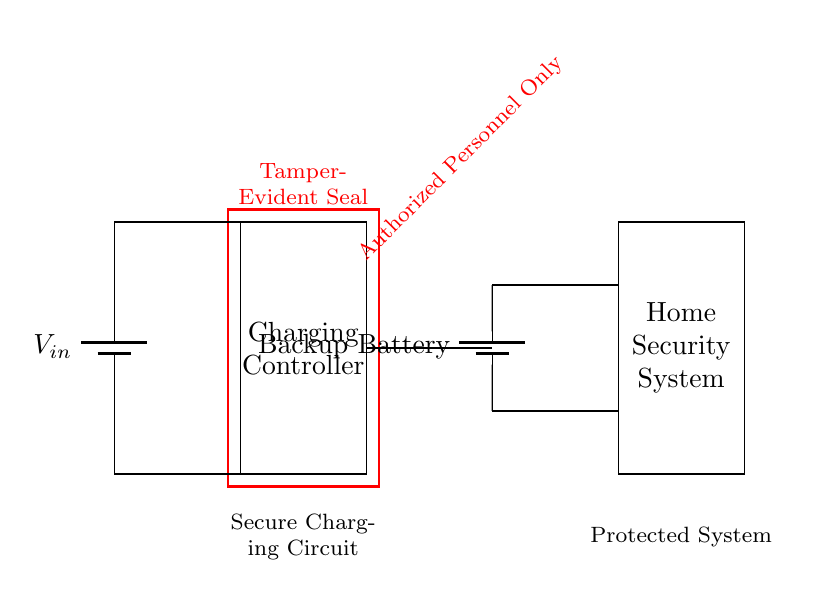What is the input voltage in this circuit? The input voltage is indicated as V in, which represents the voltage supplied to the charging circuit.
Answer: V in How many main components are in the circuit? There are four main components: a battery, a charging controller, a tamper-evident seal, and a home security system.
Answer: Four What is the purpose of the tamper-evident seal? The tamper-evident seal serves to protect the circuit from unauthorized access, ensuring that only authorized personnel can interact with the system.
Answer: Protects against tampering What happens to the backup battery during charging? During charging, the backup battery receives power from the input voltage through the charging controller, which regulates the process.
Answer: Receives power How does the circuit ensure secure charging? The charging circuit ensures secure charging by incorporating the tamper-evident seal that visually indicates if unauthorized access has occurred, alongside the regulated charging process from the controller.
Answer: Through tamper-evident seal and controller What is the connection between the charging controller and the backup battery? The charging controller connects to the backup battery, allowing it to manage the charging process and ensure the battery functions correctly within the circuit.
Answer: Manages charging process How does the security system receive power from the backup battery? The security system receives power from the backup battery directly through established connections shown in the diagram, ensuring it operates even when the main power is interrupted.
Answer: Direct connections to battery 